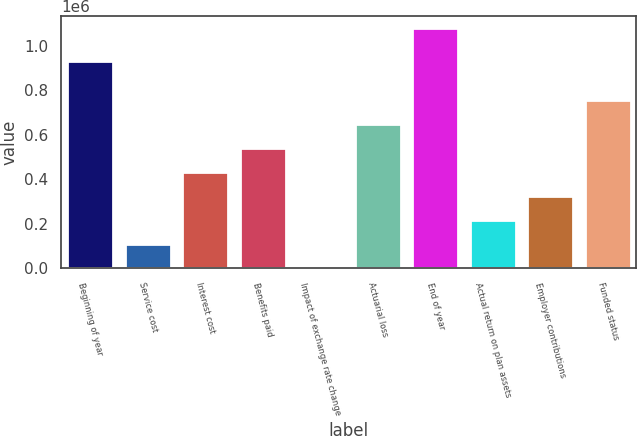<chart> <loc_0><loc_0><loc_500><loc_500><bar_chart><fcel>Beginning of year<fcel>Service cost<fcel>Interest cost<fcel>Benefits paid<fcel>Impact of exchange rate change<fcel>Actuarial loss<fcel>End of year<fcel>Actual return on plan assets<fcel>Employer contributions<fcel>Funded status<nl><fcel>931621<fcel>108261<fcel>432229<fcel>540219<fcel>271<fcel>648209<fcel>1.08017e+06<fcel>216250<fcel>324240<fcel>756198<nl></chart> 